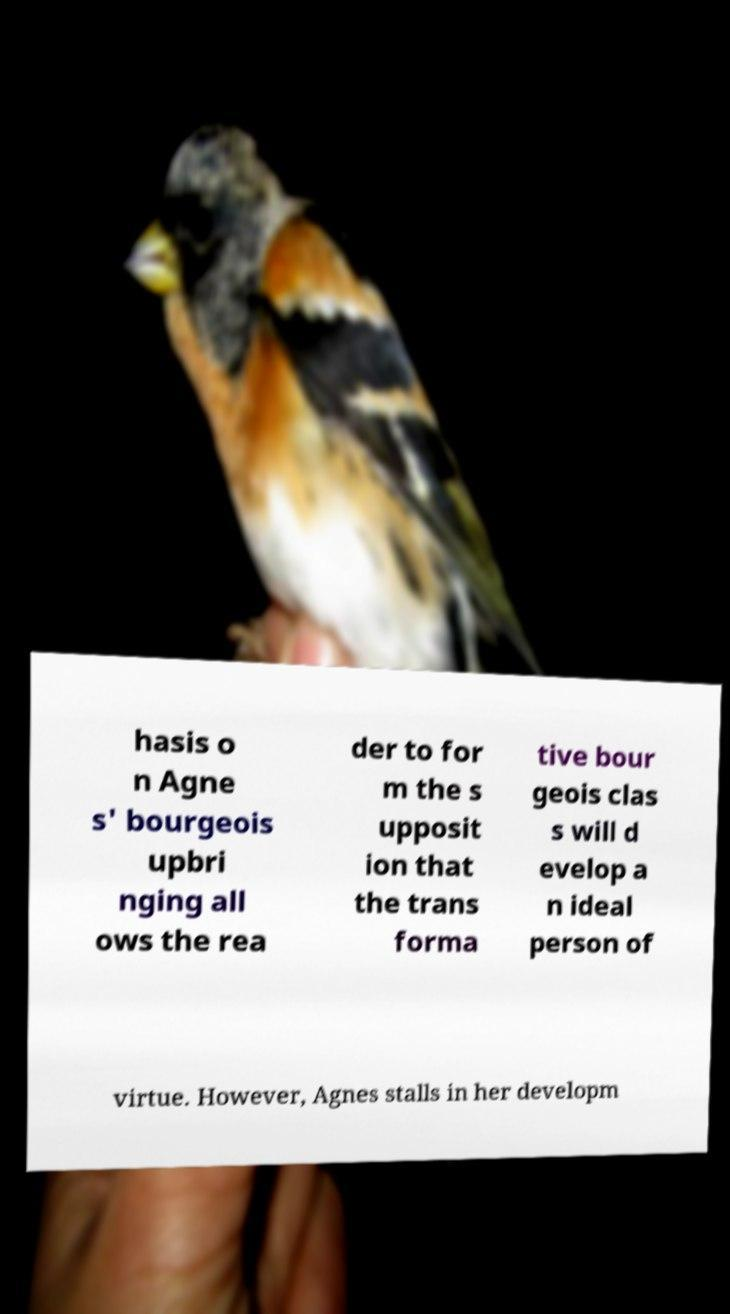Please identify and transcribe the text found in this image. hasis o n Agne s' bourgeois upbri nging all ows the rea der to for m the s upposit ion that the trans forma tive bour geois clas s will d evelop a n ideal person of virtue. However, Agnes stalls in her developm 